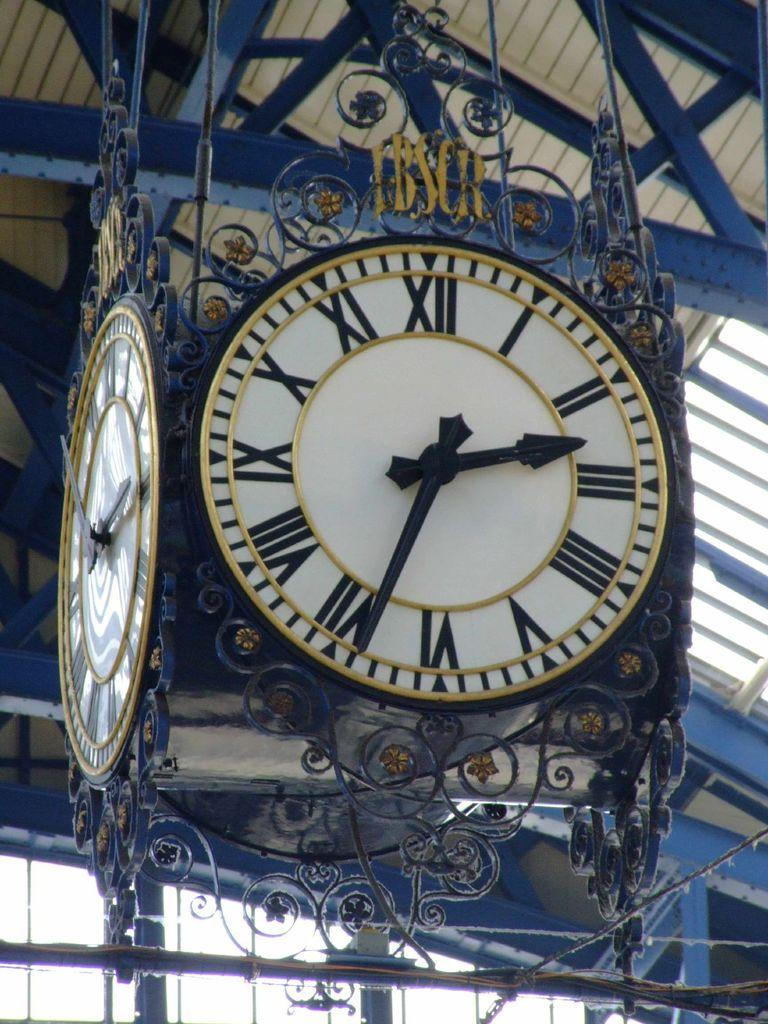What objects are hanging in the image? There are clocks hanging in the image. Where are the clocks attached in the image? The clocks are hanging from the roof. What type of material can be seen in the image in the image? There are iron rods in the image. Can you hear the animals laughing at the zoo in the image? There is no zoo or animals present in the image, and therefore no laughter can be heard. Are there any tomatoes growing on the iron rods in the image? There are no tomatoes visible in the image; only clocks and iron rods can be seen. 